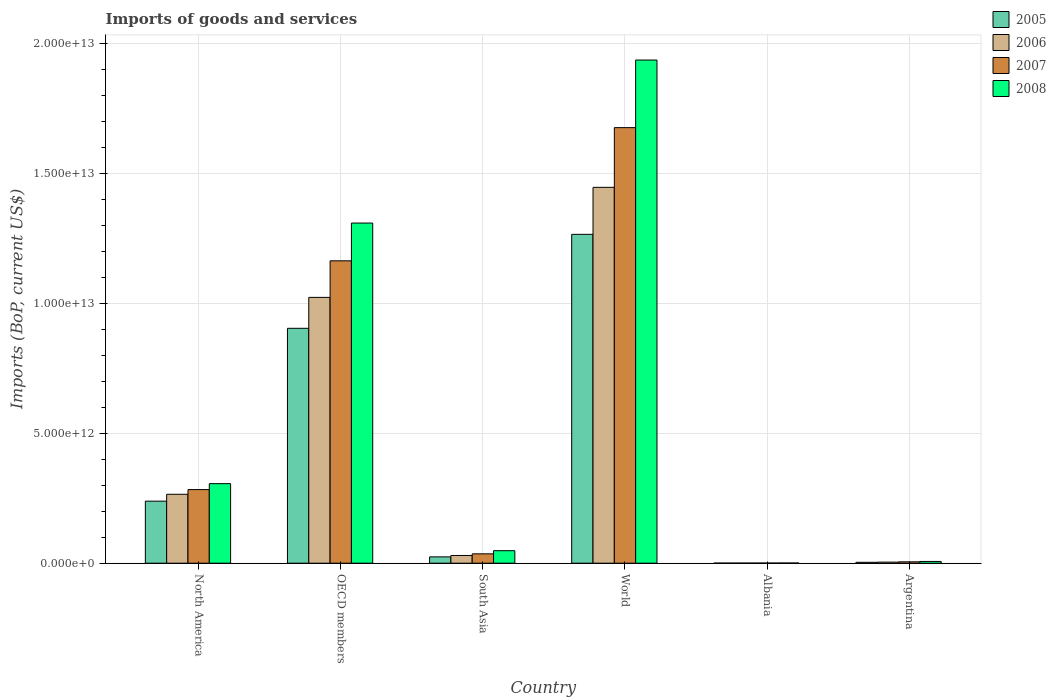How many different coloured bars are there?
Make the answer very short. 4. Are the number of bars on each tick of the X-axis equal?
Keep it short and to the point. Yes. How many bars are there on the 6th tick from the left?
Keep it short and to the point. 4. What is the label of the 5th group of bars from the left?
Offer a very short reply. Albania. In how many cases, is the number of bars for a given country not equal to the number of legend labels?
Offer a terse response. 0. What is the amount spent on imports in 2005 in OECD members?
Ensure brevity in your answer.  9.04e+12. Across all countries, what is the maximum amount spent on imports in 2005?
Your answer should be very brief. 1.27e+13. Across all countries, what is the minimum amount spent on imports in 2005?
Provide a short and direct response. 3.50e+09. In which country was the amount spent on imports in 2008 minimum?
Ensure brevity in your answer.  Albania. What is the total amount spent on imports in 2006 in the graph?
Make the answer very short. 2.77e+13. What is the difference between the amount spent on imports in 2006 in Argentina and that in World?
Make the answer very short. -1.44e+13. What is the difference between the amount spent on imports in 2005 in Argentina and the amount spent on imports in 2006 in Albania?
Provide a succinct answer. 3.07e+1. What is the average amount spent on imports in 2007 per country?
Make the answer very short. 5.27e+12. What is the difference between the amount spent on imports of/in 2007 and amount spent on imports of/in 2008 in North America?
Give a very brief answer. -2.28e+11. What is the ratio of the amount spent on imports in 2006 in Albania to that in South Asia?
Give a very brief answer. 0.01. Is the amount spent on imports in 2008 in Albania less than that in Argentina?
Offer a very short reply. Yes. Is the difference between the amount spent on imports in 2007 in Albania and OECD members greater than the difference between the amount spent on imports in 2008 in Albania and OECD members?
Keep it short and to the point. Yes. What is the difference between the highest and the second highest amount spent on imports in 2006?
Make the answer very short. 4.23e+12. What is the difference between the highest and the lowest amount spent on imports in 2005?
Offer a very short reply. 1.26e+13. In how many countries, is the amount spent on imports in 2006 greater than the average amount spent on imports in 2006 taken over all countries?
Your answer should be compact. 2. What does the 2nd bar from the right in North America represents?
Offer a very short reply. 2007. Is it the case that in every country, the sum of the amount spent on imports in 2006 and amount spent on imports in 2007 is greater than the amount spent on imports in 2008?
Provide a short and direct response. Yes. How many bars are there?
Give a very brief answer. 24. What is the difference between two consecutive major ticks on the Y-axis?
Give a very brief answer. 5.00e+12. Are the values on the major ticks of Y-axis written in scientific E-notation?
Your response must be concise. Yes. What is the title of the graph?
Ensure brevity in your answer.  Imports of goods and services. What is the label or title of the X-axis?
Your answer should be compact. Country. What is the label or title of the Y-axis?
Keep it short and to the point. Imports (BoP, current US$). What is the Imports (BoP, current US$) in 2005 in North America?
Keep it short and to the point. 2.39e+12. What is the Imports (BoP, current US$) in 2006 in North America?
Make the answer very short. 2.65e+12. What is the Imports (BoP, current US$) in 2007 in North America?
Provide a succinct answer. 2.83e+12. What is the Imports (BoP, current US$) of 2008 in North America?
Your answer should be very brief. 3.06e+12. What is the Imports (BoP, current US$) in 2005 in OECD members?
Your answer should be compact. 9.04e+12. What is the Imports (BoP, current US$) of 2006 in OECD members?
Keep it short and to the point. 1.02e+13. What is the Imports (BoP, current US$) in 2007 in OECD members?
Offer a terse response. 1.16e+13. What is the Imports (BoP, current US$) in 2008 in OECD members?
Your answer should be compact. 1.31e+13. What is the Imports (BoP, current US$) of 2005 in South Asia?
Provide a short and direct response. 2.43e+11. What is the Imports (BoP, current US$) in 2006 in South Asia?
Offer a very short reply. 2.97e+11. What is the Imports (BoP, current US$) in 2007 in South Asia?
Provide a short and direct response. 3.61e+11. What is the Imports (BoP, current US$) of 2008 in South Asia?
Offer a terse response. 4.81e+11. What is the Imports (BoP, current US$) of 2005 in World?
Offer a terse response. 1.27e+13. What is the Imports (BoP, current US$) in 2006 in World?
Your response must be concise. 1.45e+13. What is the Imports (BoP, current US$) in 2007 in World?
Give a very brief answer. 1.68e+13. What is the Imports (BoP, current US$) in 2008 in World?
Your answer should be very brief. 1.94e+13. What is the Imports (BoP, current US$) in 2005 in Albania?
Give a very brief answer. 3.50e+09. What is the Imports (BoP, current US$) in 2006 in Albania?
Give a very brief answer. 4.07e+09. What is the Imports (BoP, current US$) in 2007 in Albania?
Offer a very short reply. 5.34e+09. What is the Imports (BoP, current US$) in 2008 in Albania?
Offer a very short reply. 6.73e+09. What is the Imports (BoP, current US$) in 2005 in Argentina?
Provide a succinct answer. 3.48e+1. What is the Imports (BoP, current US$) of 2006 in Argentina?
Ensure brevity in your answer.  4.10e+1. What is the Imports (BoP, current US$) of 2007 in Argentina?
Make the answer very short. 5.32e+1. What is the Imports (BoP, current US$) of 2008 in Argentina?
Offer a terse response. 6.79e+1. Across all countries, what is the maximum Imports (BoP, current US$) in 2005?
Ensure brevity in your answer.  1.27e+13. Across all countries, what is the maximum Imports (BoP, current US$) in 2006?
Give a very brief answer. 1.45e+13. Across all countries, what is the maximum Imports (BoP, current US$) in 2007?
Offer a terse response. 1.68e+13. Across all countries, what is the maximum Imports (BoP, current US$) of 2008?
Your answer should be very brief. 1.94e+13. Across all countries, what is the minimum Imports (BoP, current US$) of 2005?
Offer a terse response. 3.50e+09. Across all countries, what is the minimum Imports (BoP, current US$) in 2006?
Provide a succinct answer. 4.07e+09. Across all countries, what is the minimum Imports (BoP, current US$) of 2007?
Offer a terse response. 5.34e+09. Across all countries, what is the minimum Imports (BoP, current US$) of 2008?
Make the answer very short. 6.73e+09. What is the total Imports (BoP, current US$) in 2005 in the graph?
Offer a very short reply. 2.44e+13. What is the total Imports (BoP, current US$) of 2006 in the graph?
Ensure brevity in your answer.  2.77e+13. What is the total Imports (BoP, current US$) in 2007 in the graph?
Ensure brevity in your answer.  3.16e+13. What is the total Imports (BoP, current US$) of 2008 in the graph?
Provide a succinct answer. 3.61e+13. What is the difference between the Imports (BoP, current US$) in 2005 in North America and that in OECD members?
Offer a very short reply. -6.65e+12. What is the difference between the Imports (BoP, current US$) of 2006 in North America and that in OECD members?
Your answer should be very brief. -7.57e+12. What is the difference between the Imports (BoP, current US$) in 2007 in North America and that in OECD members?
Your response must be concise. -8.80e+12. What is the difference between the Imports (BoP, current US$) in 2008 in North America and that in OECD members?
Your response must be concise. -1.00e+13. What is the difference between the Imports (BoP, current US$) in 2005 in North America and that in South Asia?
Provide a succinct answer. 2.14e+12. What is the difference between the Imports (BoP, current US$) of 2006 in North America and that in South Asia?
Provide a short and direct response. 2.35e+12. What is the difference between the Imports (BoP, current US$) of 2007 in North America and that in South Asia?
Provide a short and direct response. 2.47e+12. What is the difference between the Imports (BoP, current US$) of 2008 in North America and that in South Asia?
Offer a terse response. 2.58e+12. What is the difference between the Imports (BoP, current US$) in 2005 in North America and that in World?
Offer a terse response. -1.03e+13. What is the difference between the Imports (BoP, current US$) in 2006 in North America and that in World?
Offer a very short reply. -1.18e+13. What is the difference between the Imports (BoP, current US$) in 2007 in North America and that in World?
Offer a very short reply. -1.39e+13. What is the difference between the Imports (BoP, current US$) of 2008 in North America and that in World?
Provide a succinct answer. -1.63e+13. What is the difference between the Imports (BoP, current US$) of 2005 in North America and that in Albania?
Ensure brevity in your answer.  2.38e+12. What is the difference between the Imports (BoP, current US$) of 2006 in North America and that in Albania?
Make the answer very short. 2.65e+12. What is the difference between the Imports (BoP, current US$) in 2007 in North America and that in Albania?
Provide a succinct answer. 2.83e+12. What is the difference between the Imports (BoP, current US$) of 2008 in North America and that in Albania?
Make the answer very short. 3.05e+12. What is the difference between the Imports (BoP, current US$) in 2005 in North America and that in Argentina?
Provide a succinct answer. 2.35e+12. What is the difference between the Imports (BoP, current US$) in 2006 in North America and that in Argentina?
Your answer should be very brief. 2.61e+12. What is the difference between the Imports (BoP, current US$) in 2007 in North America and that in Argentina?
Your response must be concise. 2.78e+12. What is the difference between the Imports (BoP, current US$) in 2008 in North America and that in Argentina?
Offer a very short reply. 2.99e+12. What is the difference between the Imports (BoP, current US$) of 2005 in OECD members and that in South Asia?
Make the answer very short. 8.79e+12. What is the difference between the Imports (BoP, current US$) of 2006 in OECD members and that in South Asia?
Offer a very short reply. 9.93e+12. What is the difference between the Imports (BoP, current US$) in 2007 in OECD members and that in South Asia?
Offer a very short reply. 1.13e+13. What is the difference between the Imports (BoP, current US$) in 2008 in OECD members and that in South Asia?
Provide a succinct answer. 1.26e+13. What is the difference between the Imports (BoP, current US$) of 2005 in OECD members and that in World?
Give a very brief answer. -3.62e+12. What is the difference between the Imports (BoP, current US$) in 2006 in OECD members and that in World?
Your response must be concise. -4.23e+12. What is the difference between the Imports (BoP, current US$) in 2007 in OECD members and that in World?
Your response must be concise. -5.12e+12. What is the difference between the Imports (BoP, current US$) in 2008 in OECD members and that in World?
Make the answer very short. -6.27e+12. What is the difference between the Imports (BoP, current US$) of 2005 in OECD members and that in Albania?
Ensure brevity in your answer.  9.03e+12. What is the difference between the Imports (BoP, current US$) in 2006 in OECD members and that in Albania?
Ensure brevity in your answer.  1.02e+13. What is the difference between the Imports (BoP, current US$) in 2007 in OECD members and that in Albania?
Provide a succinct answer. 1.16e+13. What is the difference between the Imports (BoP, current US$) of 2008 in OECD members and that in Albania?
Give a very brief answer. 1.31e+13. What is the difference between the Imports (BoP, current US$) in 2005 in OECD members and that in Argentina?
Make the answer very short. 9.00e+12. What is the difference between the Imports (BoP, current US$) of 2006 in OECD members and that in Argentina?
Ensure brevity in your answer.  1.02e+13. What is the difference between the Imports (BoP, current US$) in 2007 in OECD members and that in Argentina?
Your response must be concise. 1.16e+13. What is the difference between the Imports (BoP, current US$) of 2008 in OECD members and that in Argentina?
Keep it short and to the point. 1.30e+13. What is the difference between the Imports (BoP, current US$) of 2005 in South Asia and that in World?
Provide a short and direct response. -1.24e+13. What is the difference between the Imports (BoP, current US$) of 2006 in South Asia and that in World?
Give a very brief answer. -1.42e+13. What is the difference between the Imports (BoP, current US$) of 2007 in South Asia and that in World?
Your response must be concise. -1.64e+13. What is the difference between the Imports (BoP, current US$) in 2008 in South Asia and that in World?
Offer a terse response. -1.89e+13. What is the difference between the Imports (BoP, current US$) in 2005 in South Asia and that in Albania?
Your response must be concise. 2.40e+11. What is the difference between the Imports (BoP, current US$) of 2006 in South Asia and that in Albania?
Your answer should be compact. 2.93e+11. What is the difference between the Imports (BoP, current US$) in 2007 in South Asia and that in Albania?
Offer a very short reply. 3.55e+11. What is the difference between the Imports (BoP, current US$) of 2008 in South Asia and that in Albania?
Make the answer very short. 4.74e+11. What is the difference between the Imports (BoP, current US$) of 2005 in South Asia and that in Argentina?
Offer a terse response. 2.09e+11. What is the difference between the Imports (BoP, current US$) in 2006 in South Asia and that in Argentina?
Ensure brevity in your answer.  2.56e+11. What is the difference between the Imports (BoP, current US$) of 2007 in South Asia and that in Argentina?
Offer a terse response. 3.07e+11. What is the difference between the Imports (BoP, current US$) of 2008 in South Asia and that in Argentina?
Your answer should be very brief. 4.13e+11. What is the difference between the Imports (BoP, current US$) in 2005 in World and that in Albania?
Keep it short and to the point. 1.26e+13. What is the difference between the Imports (BoP, current US$) in 2006 in World and that in Albania?
Offer a terse response. 1.45e+13. What is the difference between the Imports (BoP, current US$) of 2007 in World and that in Albania?
Provide a succinct answer. 1.68e+13. What is the difference between the Imports (BoP, current US$) of 2008 in World and that in Albania?
Your response must be concise. 1.93e+13. What is the difference between the Imports (BoP, current US$) in 2005 in World and that in Argentina?
Give a very brief answer. 1.26e+13. What is the difference between the Imports (BoP, current US$) of 2006 in World and that in Argentina?
Ensure brevity in your answer.  1.44e+13. What is the difference between the Imports (BoP, current US$) in 2007 in World and that in Argentina?
Make the answer very short. 1.67e+13. What is the difference between the Imports (BoP, current US$) in 2008 in World and that in Argentina?
Your response must be concise. 1.93e+13. What is the difference between the Imports (BoP, current US$) of 2005 in Albania and that in Argentina?
Your answer should be compact. -3.13e+1. What is the difference between the Imports (BoP, current US$) of 2006 in Albania and that in Argentina?
Ensure brevity in your answer.  -3.69e+1. What is the difference between the Imports (BoP, current US$) of 2007 in Albania and that in Argentina?
Make the answer very short. -4.79e+1. What is the difference between the Imports (BoP, current US$) of 2008 in Albania and that in Argentina?
Provide a short and direct response. -6.11e+1. What is the difference between the Imports (BoP, current US$) in 2005 in North America and the Imports (BoP, current US$) in 2006 in OECD members?
Give a very brief answer. -7.84e+12. What is the difference between the Imports (BoP, current US$) of 2005 in North America and the Imports (BoP, current US$) of 2007 in OECD members?
Your answer should be compact. -9.25e+12. What is the difference between the Imports (BoP, current US$) in 2005 in North America and the Imports (BoP, current US$) in 2008 in OECD members?
Your answer should be very brief. -1.07e+13. What is the difference between the Imports (BoP, current US$) in 2006 in North America and the Imports (BoP, current US$) in 2007 in OECD members?
Make the answer very short. -8.98e+12. What is the difference between the Imports (BoP, current US$) of 2006 in North America and the Imports (BoP, current US$) of 2008 in OECD members?
Your response must be concise. -1.04e+13. What is the difference between the Imports (BoP, current US$) of 2007 in North America and the Imports (BoP, current US$) of 2008 in OECD members?
Your answer should be very brief. -1.03e+13. What is the difference between the Imports (BoP, current US$) in 2005 in North America and the Imports (BoP, current US$) in 2006 in South Asia?
Your answer should be compact. 2.09e+12. What is the difference between the Imports (BoP, current US$) of 2005 in North America and the Imports (BoP, current US$) of 2007 in South Asia?
Give a very brief answer. 2.03e+12. What is the difference between the Imports (BoP, current US$) in 2005 in North America and the Imports (BoP, current US$) in 2008 in South Asia?
Offer a very short reply. 1.91e+12. What is the difference between the Imports (BoP, current US$) of 2006 in North America and the Imports (BoP, current US$) of 2007 in South Asia?
Offer a very short reply. 2.29e+12. What is the difference between the Imports (BoP, current US$) of 2006 in North America and the Imports (BoP, current US$) of 2008 in South Asia?
Offer a terse response. 2.17e+12. What is the difference between the Imports (BoP, current US$) in 2007 in North America and the Imports (BoP, current US$) in 2008 in South Asia?
Offer a terse response. 2.35e+12. What is the difference between the Imports (BoP, current US$) in 2005 in North America and the Imports (BoP, current US$) in 2006 in World?
Make the answer very short. -1.21e+13. What is the difference between the Imports (BoP, current US$) in 2005 in North America and the Imports (BoP, current US$) in 2007 in World?
Offer a very short reply. -1.44e+13. What is the difference between the Imports (BoP, current US$) in 2005 in North America and the Imports (BoP, current US$) in 2008 in World?
Offer a very short reply. -1.70e+13. What is the difference between the Imports (BoP, current US$) in 2006 in North America and the Imports (BoP, current US$) in 2007 in World?
Offer a terse response. -1.41e+13. What is the difference between the Imports (BoP, current US$) of 2006 in North America and the Imports (BoP, current US$) of 2008 in World?
Make the answer very short. -1.67e+13. What is the difference between the Imports (BoP, current US$) in 2007 in North America and the Imports (BoP, current US$) in 2008 in World?
Your answer should be very brief. -1.65e+13. What is the difference between the Imports (BoP, current US$) of 2005 in North America and the Imports (BoP, current US$) of 2006 in Albania?
Provide a short and direct response. 2.38e+12. What is the difference between the Imports (BoP, current US$) in 2005 in North America and the Imports (BoP, current US$) in 2007 in Albania?
Ensure brevity in your answer.  2.38e+12. What is the difference between the Imports (BoP, current US$) in 2005 in North America and the Imports (BoP, current US$) in 2008 in Albania?
Your response must be concise. 2.38e+12. What is the difference between the Imports (BoP, current US$) of 2006 in North America and the Imports (BoP, current US$) of 2007 in Albania?
Provide a succinct answer. 2.65e+12. What is the difference between the Imports (BoP, current US$) in 2006 in North America and the Imports (BoP, current US$) in 2008 in Albania?
Ensure brevity in your answer.  2.64e+12. What is the difference between the Imports (BoP, current US$) of 2007 in North America and the Imports (BoP, current US$) of 2008 in Albania?
Your response must be concise. 2.83e+12. What is the difference between the Imports (BoP, current US$) of 2005 in North America and the Imports (BoP, current US$) of 2006 in Argentina?
Provide a succinct answer. 2.35e+12. What is the difference between the Imports (BoP, current US$) of 2005 in North America and the Imports (BoP, current US$) of 2007 in Argentina?
Give a very brief answer. 2.33e+12. What is the difference between the Imports (BoP, current US$) of 2005 in North America and the Imports (BoP, current US$) of 2008 in Argentina?
Your answer should be very brief. 2.32e+12. What is the difference between the Imports (BoP, current US$) of 2006 in North America and the Imports (BoP, current US$) of 2007 in Argentina?
Offer a terse response. 2.60e+12. What is the difference between the Imports (BoP, current US$) of 2006 in North America and the Imports (BoP, current US$) of 2008 in Argentina?
Your response must be concise. 2.58e+12. What is the difference between the Imports (BoP, current US$) of 2007 in North America and the Imports (BoP, current US$) of 2008 in Argentina?
Offer a very short reply. 2.76e+12. What is the difference between the Imports (BoP, current US$) of 2005 in OECD members and the Imports (BoP, current US$) of 2006 in South Asia?
Make the answer very short. 8.74e+12. What is the difference between the Imports (BoP, current US$) in 2005 in OECD members and the Imports (BoP, current US$) in 2007 in South Asia?
Offer a terse response. 8.68e+12. What is the difference between the Imports (BoP, current US$) of 2005 in OECD members and the Imports (BoP, current US$) of 2008 in South Asia?
Offer a terse response. 8.55e+12. What is the difference between the Imports (BoP, current US$) of 2006 in OECD members and the Imports (BoP, current US$) of 2007 in South Asia?
Offer a very short reply. 9.87e+12. What is the difference between the Imports (BoP, current US$) of 2006 in OECD members and the Imports (BoP, current US$) of 2008 in South Asia?
Your answer should be compact. 9.74e+12. What is the difference between the Imports (BoP, current US$) in 2007 in OECD members and the Imports (BoP, current US$) in 2008 in South Asia?
Your response must be concise. 1.12e+13. What is the difference between the Imports (BoP, current US$) of 2005 in OECD members and the Imports (BoP, current US$) of 2006 in World?
Ensure brevity in your answer.  -5.42e+12. What is the difference between the Imports (BoP, current US$) of 2005 in OECD members and the Imports (BoP, current US$) of 2007 in World?
Give a very brief answer. -7.72e+12. What is the difference between the Imports (BoP, current US$) of 2005 in OECD members and the Imports (BoP, current US$) of 2008 in World?
Make the answer very short. -1.03e+13. What is the difference between the Imports (BoP, current US$) of 2006 in OECD members and the Imports (BoP, current US$) of 2007 in World?
Keep it short and to the point. -6.53e+12. What is the difference between the Imports (BoP, current US$) in 2006 in OECD members and the Imports (BoP, current US$) in 2008 in World?
Provide a succinct answer. -9.13e+12. What is the difference between the Imports (BoP, current US$) in 2007 in OECD members and the Imports (BoP, current US$) in 2008 in World?
Make the answer very short. -7.72e+12. What is the difference between the Imports (BoP, current US$) of 2005 in OECD members and the Imports (BoP, current US$) of 2006 in Albania?
Provide a succinct answer. 9.03e+12. What is the difference between the Imports (BoP, current US$) of 2005 in OECD members and the Imports (BoP, current US$) of 2007 in Albania?
Your answer should be compact. 9.03e+12. What is the difference between the Imports (BoP, current US$) of 2005 in OECD members and the Imports (BoP, current US$) of 2008 in Albania?
Your answer should be very brief. 9.03e+12. What is the difference between the Imports (BoP, current US$) of 2006 in OECD members and the Imports (BoP, current US$) of 2007 in Albania?
Your answer should be compact. 1.02e+13. What is the difference between the Imports (BoP, current US$) of 2006 in OECD members and the Imports (BoP, current US$) of 2008 in Albania?
Keep it short and to the point. 1.02e+13. What is the difference between the Imports (BoP, current US$) of 2007 in OECD members and the Imports (BoP, current US$) of 2008 in Albania?
Ensure brevity in your answer.  1.16e+13. What is the difference between the Imports (BoP, current US$) of 2005 in OECD members and the Imports (BoP, current US$) of 2006 in Argentina?
Your response must be concise. 9.00e+12. What is the difference between the Imports (BoP, current US$) of 2005 in OECD members and the Imports (BoP, current US$) of 2007 in Argentina?
Provide a succinct answer. 8.98e+12. What is the difference between the Imports (BoP, current US$) in 2005 in OECD members and the Imports (BoP, current US$) in 2008 in Argentina?
Your answer should be compact. 8.97e+12. What is the difference between the Imports (BoP, current US$) in 2006 in OECD members and the Imports (BoP, current US$) in 2007 in Argentina?
Make the answer very short. 1.02e+13. What is the difference between the Imports (BoP, current US$) in 2006 in OECD members and the Imports (BoP, current US$) in 2008 in Argentina?
Offer a terse response. 1.02e+13. What is the difference between the Imports (BoP, current US$) in 2007 in OECD members and the Imports (BoP, current US$) in 2008 in Argentina?
Give a very brief answer. 1.16e+13. What is the difference between the Imports (BoP, current US$) in 2005 in South Asia and the Imports (BoP, current US$) in 2006 in World?
Provide a succinct answer. -1.42e+13. What is the difference between the Imports (BoP, current US$) of 2005 in South Asia and the Imports (BoP, current US$) of 2007 in World?
Offer a very short reply. -1.65e+13. What is the difference between the Imports (BoP, current US$) in 2005 in South Asia and the Imports (BoP, current US$) in 2008 in World?
Give a very brief answer. -1.91e+13. What is the difference between the Imports (BoP, current US$) of 2006 in South Asia and the Imports (BoP, current US$) of 2007 in World?
Provide a succinct answer. -1.65e+13. What is the difference between the Imports (BoP, current US$) of 2006 in South Asia and the Imports (BoP, current US$) of 2008 in World?
Offer a terse response. -1.91e+13. What is the difference between the Imports (BoP, current US$) of 2007 in South Asia and the Imports (BoP, current US$) of 2008 in World?
Make the answer very short. -1.90e+13. What is the difference between the Imports (BoP, current US$) of 2005 in South Asia and the Imports (BoP, current US$) of 2006 in Albania?
Provide a succinct answer. 2.39e+11. What is the difference between the Imports (BoP, current US$) in 2005 in South Asia and the Imports (BoP, current US$) in 2007 in Albania?
Provide a succinct answer. 2.38e+11. What is the difference between the Imports (BoP, current US$) of 2005 in South Asia and the Imports (BoP, current US$) of 2008 in Albania?
Provide a succinct answer. 2.37e+11. What is the difference between the Imports (BoP, current US$) of 2006 in South Asia and the Imports (BoP, current US$) of 2007 in Albania?
Give a very brief answer. 2.92e+11. What is the difference between the Imports (BoP, current US$) in 2006 in South Asia and the Imports (BoP, current US$) in 2008 in Albania?
Ensure brevity in your answer.  2.91e+11. What is the difference between the Imports (BoP, current US$) in 2007 in South Asia and the Imports (BoP, current US$) in 2008 in Albania?
Provide a succinct answer. 3.54e+11. What is the difference between the Imports (BoP, current US$) in 2005 in South Asia and the Imports (BoP, current US$) in 2006 in Argentina?
Your answer should be very brief. 2.02e+11. What is the difference between the Imports (BoP, current US$) in 2005 in South Asia and the Imports (BoP, current US$) in 2007 in Argentina?
Offer a terse response. 1.90e+11. What is the difference between the Imports (BoP, current US$) in 2005 in South Asia and the Imports (BoP, current US$) in 2008 in Argentina?
Your answer should be very brief. 1.76e+11. What is the difference between the Imports (BoP, current US$) in 2006 in South Asia and the Imports (BoP, current US$) in 2007 in Argentina?
Your answer should be compact. 2.44e+11. What is the difference between the Imports (BoP, current US$) in 2006 in South Asia and the Imports (BoP, current US$) in 2008 in Argentina?
Your response must be concise. 2.30e+11. What is the difference between the Imports (BoP, current US$) of 2007 in South Asia and the Imports (BoP, current US$) of 2008 in Argentina?
Your response must be concise. 2.93e+11. What is the difference between the Imports (BoP, current US$) in 2005 in World and the Imports (BoP, current US$) in 2006 in Albania?
Provide a short and direct response. 1.26e+13. What is the difference between the Imports (BoP, current US$) in 2005 in World and the Imports (BoP, current US$) in 2007 in Albania?
Give a very brief answer. 1.26e+13. What is the difference between the Imports (BoP, current US$) in 2005 in World and the Imports (BoP, current US$) in 2008 in Albania?
Give a very brief answer. 1.26e+13. What is the difference between the Imports (BoP, current US$) in 2006 in World and the Imports (BoP, current US$) in 2007 in Albania?
Provide a short and direct response. 1.45e+13. What is the difference between the Imports (BoP, current US$) in 2006 in World and the Imports (BoP, current US$) in 2008 in Albania?
Ensure brevity in your answer.  1.45e+13. What is the difference between the Imports (BoP, current US$) of 2007 in World and the Imports (BoP, current US$) of 2008 in Albania?
Your response must be concise. 1.67e+13. What is the difference between the Imports (BoP, current US$) of 2005 in World and the Imports (BoP, current US$) of 2006 in Argentina?
Offer a very short reply. 1.26e+13. What is the difference between the Imports (BoP, current US$) of 2005 in World and the Imports (BoP, current US$) of 2007 in Argentina?
Provide a succinct answer. 1.26e+13. What is the difference between the Imports (BoP, current US$) in 2005 in World and the Imports (BoP, current US$) in 2008 in Argentina?
Provide a short and direct response. 1.26e+13. What is the difference between the Imports (BoP, current US$) of 2006 in World and the Imports (BoP, current US$) of 2007 in Argentina?
Keep it short and to the point. 1.44e+13. What is the difference between the Imports (BoP, current US$) in 2006 in World and the Imports (BoP, current US$) in 2008 in Argentina?
Your response must be concise. 1.44e+13. What is the difference between the Imports (BoP, current US$) in 2007 in World and the Imports (BoP, current US$) in 2008 in Argentina?
Your answer should be compact. 1.67e+13. What is the difference between the Imports (BoP, current US$) of 2005 in Albania and the Imports (BoP, current US$) of 2006 in Argentina?
Ensure brevity in your answer.  -3.75e+1. What is the difference between the Imports (BoP, current US$) in 2005 in Albania and the Imports (BoP, current US$) in 2007 in Argentina?
Your answer should be compact. -4.97e+1. What is the difference between the Imports (BoP, current US$) of 2005 in Albania and the Imports (BoP, current US$) of 2008 in Argentina?
Provide a short and direct response. -6.43e+1. What is the difference between the Imports (BoP, current US$) of 2006 in Albania and the Imports (BoP, current US$) of 2007 in Argentina?
Your answer should be compact. -4.92e+1. What is the difference between the Imports (BoP, current US$) of 2006 in Albania and the Imports (BoP, current US$) of 2008 in Argentina?
Ensure brevity in your answer.  -6.38e+1. What is the difference between the Imports (BoP, current US$) of 2007 in Albania and the Imports (BoP, current US$) of 2008 in Argentina?
Your answer should be compact. -6.25e+1. What is the average Imports (BoP, current US$) in 2005 per country?
Offer a very short reply. 4.06e+12. What is the average Imports (BoP, current US$) in 2006 per country?
Make the answer very short. 4.61e+12. What is the average Imports (BoP, current US$) of 2007 per country?
Keep it short and to the point. 5.27e+12. What is the average Imports (BoP, current US$) of 2008 per country?
Offer a very short reply. 6.01e+12. What is the difference between the Imports (BoP, current US$) of 2005 and Imports (BoP, current US$) of 2006 in North America?
Offer a very short reply. -2.65e+11. What is the difference between the Imports (BoP, current US$) of 2005 and Imports (BoP, current US$) of 2007 in North America?
Make the answer very short. -4.46e+11. What is the difference between the Imports (BoP, current US$) in 2005 and Imports (BoP, current US$) in 2008 in North America?
Provide a short and direct response. -6.74e+11. What is the difference between the Imports (BoP, current US$) in 2006 and Imports (BoP, current US$) in 2007 in North America?
Offer a terse response. -1.81e+11. What is the difference between the Imports (BoP, current US$) in 2006 and Imports (BoP, current US$) in 2008 in North America?
Provide a succinct answer. -4.09e+11. What is the difference between the Imports (BoP, current US$) in 2007 and Imports (BoP, current US$) in 2008 in North America?
Your answer should be compact. -2.28e+11. What is the difference between the Imports (BoP, current US$) in 2005 and Imports (BoP, current US$) in 2006 in OECD members?
Keep it short and to the point. -1.19e+12. What is the difference between the Imports (BoP, current US$) of 2005 and Imports (BoP, current US$) of 2007 in OECD members?
Offer a very short reply. -2.60e+12. What is the difference between the Imports (BoP, current US$) of 2005 and Imports (BoP, current US$) of 2008 in OECD members?
Ensure brevity in your answer.  -4.05e+12. What is the difference between the Imports (BoP, current US$) in 2006 and Imports (BoP, current US$) in 2007 in OECD members?
Your answer should be compact. -1.41e+12. What is the difference between the Imports (BoP, current US$) of 2006 and Imports (BoP, current US$) of 2008 in OECD members?
Ensure brevity in your answer.  -2.86e+12. What is the difference between the Imports (BoP, current US$) of 2007 and Imports (BoP, current US$) of 2008 in OECD members?
Ensure brevity in your answer.  -1.45e+12. What is the difference between the Imports (BoP, current US$) of 2005 and Imports (BoP, current US$) of 2006 in South Asia?
Your response must be concise. -5.40e+1. What is the difference between the Imports (BoP, current US$) of 2005 and Imports (BoP, current US$) of 2007 in South Asia?
Provide a short and direct response. -1.17e+11. What is the difference between the Imports (BoP, current US$) of 2005 and Imports (BoP, current US$) of 2008 in South Asia?
Offer a very short reply. -2.38e+11. What is the difference between the Imports (BoP, current US$) in 2006 and Imports (BoP, current US$) in 2007 in South Asia?
Give a very brief answer. -6.32e+1. What is the difference between the Imports (BoP, current US$) in 2006 and Imports (BoP, current US$) in 2008 in South Asia?
Provide a succinct answer. -1.84e+11. What is the difference between the Imports (BoP, current US$) of 2007 and Imports (BoP, current US$) of 2008 in South Asia?
Your answer should be compact. -1.21e+11. What is the difference between the Imports (BoP, current US$) in 2005 and Imports (BoP, current US$) in 2006 in World?
Provide a succinct answer. -1.81e+12. What is the difference between the Imports (BoP, current US$) in 2005 and Imports (BoP, current US$) in 2007 in World?
Keep it short and to the point. -4.10e+12. What is the difference between the Imports (BoP, current US$) of 2005 and Imports (BoP, current US$) of 2008 in World?
Give a very brief answer. -6.71e+12. What is the difference between the Imports (BoP, current US$) in 2006 and Imports (BoP, current US$) in 2007 in World?
Offer a terse response. -2.30e+12. What is the difference between the Imports (BoP, current US$) of 2006 and Imports (BoP, current US$) of 2008 in World?
Provide a succinct answer. -4.90e+12. What is the difference between the Imports (BoP, current US$) of 2007 and Imports (BoP, current US$) of 2008 in World?
Offer a very short reply. -2.60e+12. What is the difference between the Imports (BoP, current US$) in 2005 and Imports (BoP, current US$) in 2006 in Albania?
Provide a succinct answer. -5.73e+08. What is the difference between the Imports (BoP, current US$) in 2005 and Imports (BoP, current US$) in 2007 in Albania?
Offer a terse response. -1.84e+09. What is the difference between the Imports (BoP, current US$) in 2005 and Imports (BoP, current US$) in 2008 in Albania?
Your answer should be compact. -3.23e+09. What is the difference between the Imports (BoP, current US$) of 2006 and Imports (BoP, current US$) of 2007 in Albania?
Your response must be concise. -1.27e+09. What is the difference between the Imports (BoP, current US$) of 2006 and Imports (BoP, current US$) of 2008 in Albania?
Offer a very short reply. -2.66e+09. What is the difference between the Imports (BoP, current US$) of 2007 and Imports (BoP, current US$) of 2008 in Albania?
Offer a very short reply. -1.39e+09. What is the difference between the Imports (BoP, current US$) in 2005 and Imports (BoP, current US$) in 2006 in Argentina?
Your answer should be very brief. -6.18e+09. What is the difference between the Imports (BoP, current US$) of 2005 and Imports (BoP, current US$) of 2007 in Argentina?
Ensure brevity in your answer.  -1.84e+1. What is the difference between the Imports (BoP, current US$) of 2005 and Imports (BoP, current US$) of 2008 in Argentina?
Keep it short and to the point. -3.31e+1. What is the difference between the Imports (BoP, current US$) of 2006 and Imports (BoP, current US$) of 2007 in Argentina?
Keep it short and to the point. -1.23e+1. What is the difference between the Imports (BoP, current US$) of 2006 and Imports (BoP, current US$) of 2008 in Argentina?
Give a very brief answer. -2.69e+1. What is the difference between the Imports (BoP, current US$) of 2007 and Imports (BoP, current US$) of 2008 in Argentina?
Offer a terse response. -1.46e+1. What is the ratio of the Imports (BoP, current US$) in 2005 in North America to that in OECD members?
Your answer should be very brief. 0.26. What is the ratio of the Imports (BoP, current US$) of 2006 in North America to that in OECD members?
Your answer should be compact. 0.26. What is the ratio of the Imports (BoP, current US$) in 2007 in North America to that in OECD members?
Your response must be concise. 0.24. What is the ratio of the Imports (BoP, current US$) in 2008 in North America to that in OECD members?
Your answer should be very brief. 0.23. What is the ratio of the Imports (BoP, current US$) of 2005 in North America to that in South Asia?
Make the answer very short. 9.81. What is the ratio of the Imports (BoP, current US$) in 2006 in North America to that in South Asia?
Keep it short and to the point. 8.91. What is the ratio of the Imports (BoP, current US$) in 2007 in North America to that in South Asia?
Provide a short and direct response. 7.86. What is the ratio of the Imports (BoP, current US$) of 2008 in North America to that in South Asia?
Ensure brevity in your answer.  6.36. What is the ratio of the Imports (BoP, current US$) in 2005 in North America to that in World?
Provide a short and direct response. 0.19. What is the ratio of the Imports (BoP, current US$) in 2006 in North America to that in World?
Provide a short and direct response. 0.18. What is the ratio of the Imports (BoP, current US$) of 2007 in North America to that in World?
Your response must be concise. 0.17. What is the ratio of the Imports (BoP, current US$) in 2008 in North America to that in World?
Keep it short and to the point. 0.16. What is the ratio of the Imports (BoP, current US$) of 2005 in North America to that in Albania?
Your answer should be very brief. 681.78. What is the ratio of the Imports (BoP, current US$) of 2006 in North America to that in Albania?
Offer a very short reply. 650.85. What is the ratio of the Imports (BoP, current US$) of 2007 in North America to that in Albania?
Provide a succinct answer. 529.96. What is the ratio of the Imports (BoP, current US$) in 2008 in North America to that in Albania?
Ensure brevity in your answer.  454.64. What is the ratio of the Imports (BoP, current US$) of 2005 in North America to that in Argentina?
Provide a succinct answer. 68.58. What is the ratio of the Imports (BoP, current US$) of 2006 in North America to that in Argentina?
Ensure brevity in your answer.  64.7. What is the ratio of the Imports (BoP, current US$) in 2007 in North America to that in Argentina?
Keep it short and to the point. 53.21. What is the ratio of the Imports (BoP, current US$) in 2008 in North America to that in Argentina?
Make the answer very short. 45.1. What is the ratio of the Imports (BoP, current US$) of 2005 in OECD members to that in South Asia?
Provide a succinct answer. 37.13. What is the ratio of the Imports (BoP, current US$) in 2006 in OECD members to that in South Asia?
Provide a short and direct response. 34.39. What is the ratio of the Imports (BoP, current US$) of 2007 in OECD members to that in South Asia?
Give a very brief answer. 32.26. What is the ratio of the Imports (BoP, current US$) of 2008 in OECD members to that in South Asia?
Give a very brief answer. 27.19. What is the ratio of the Imports (BoP, current US$) of 2005 in OECD members to that in World?
Keep it short and to the point. 0.71. What is the ratio of the Imports (BoP, current US$) of 2006 in OECD members to that in World?
Give a very brief answer. 0.71. What is the ratio of the Imports (BoP, current US$) in 2007 in OECD members to that in World?
Provide a succinct answer. 0.69. What is the ratio of the Imports (BoP, current US$) of 2008 in OECD members to that in World?
Provide a short and direct response. 0.68. What is the ratio of the Imports (BoP, current US$) in 2005 in OECD members to that in Albania?
Offer a terse response. 2581.45. What is the ratio of the Imports (BoP, current US$) of 2006 in OECD members to that in Albania?
Your answer should be very brief. 2510.58. What is the ratio of the Imports (BoP, current US$) in 2007 in OECD members to that in Albania?
Give a very brief answer. 2176.63. What is the ratio of the Imports (BoP, current US$) of 2008 in OECD members to that in Albania?
Offer a terse response. 1944.04. What is the ratio of the Imports (BoP, current US$) of 2005 in OECD members to that in Argentina?
Your response must be concise. 259.68. What is the ratio of the Imports (BoP, current US$) in 2006 in OECD members to that in Argentina?
Keep it short and to the point. 249.57. What is the ratio of the Imports (BoP, current US$) in 2007 in OECD members to that in Argentina?
Keep it short and to the point. 218.54. What is the ratio of the Imports (BoP, current US$) of 2008 in OECD members to that in Argentina?
Offer a terse response. 192.85. What is the ratio of the Imports (BoP, current US$) in 2005 in South Asia to that in World?
Your answer should be compact. 0.02. What is the ratio of the Imports (BoP, current US$) in 2006 in South Asia to that in World?
Give a very brief answer. 0.02. What is the ratio of the Imports (BoP, current US$) of 2007 in South Asia to that in World?
Make the answer very short. 0.02. What is the ratio of the Imports (BoP, current US$) in 2008 in South Asia to that in World?
Offer a terse response. 0.02. What is the ratio of the Imports (BoP, current US$) of 2005 in South Asia to that in Albania?
Ensure brevity in your answer.  69.53. What is the ratio of the Imports (BoP, current US$) of 2006 in South Asia to that in Albania?
Offer a very short reply. 73.01. What is the ratio of the Imports (BoP, current US$) of 2007 in South Asia to that in Albania?
Your answer should be compact. 67.47. What is the ratio of the Imports (BoP, current US$) of 2008 in South Asia to that in Albania?
Your answer should be compact. 71.49. What is the ratio of the Imports (BoP, current US$) in 2005 in South Asia to that in Argentina?
Give a very brief answer. 6.99. What is the ratio of the Imports (BoP, current US$) in 2006 in South Asia to that in Argentina?
Offer a terse response. 7.26. What is the ratio of the Imports (BoP, current US$) of 2007 in South Asia to that in Argentina?
Give a very brief answer. 6.77. What is the ratio of the Imports (BoP, current US$) of 2008 in South Asia to that in Argentina?
Provide a short and direct response. 7.09. What is the ratio of the Imports (BoP, current US$) in 2005 in World to that in Albania?
Provide a short and direct response. 3614.24. What is the ratio of the Imports (BoP, current US$) in 2006 in World to that in Albania?
Make the answer very short. 3549.9. What is the ratio of the Imports (BoP, current US$) in 2007 in World to that in Albania?
Keep it short and to the point. 3135.35. What is the ratio of the Imports (BoP, current US$) of 2008 in World to that in Albania?
Your answer should be very brief. 2875.75. What is the ratio of the Imports (BoP, current US$) in 2005 in World to that in Argentina?
Offer a terse response. 363.57. What is the ratio of the Imports (BoP, current US$) of 2006 in World to that in Argentina?
Provide a short and direct response. 352.89. What is the ratio of the Imports (BoP, current US$) of 2007 in World to that in Argentina?
Keep it short and to the point. 314.8. What is the ratio of the Imports (BoP, current US$) of 2008 in World to that in Argentina?
Offer a terse response. 285.28. What is the ratio of the Imports (BoP, current US$) in 2005 in Albania to that in Argentina?
Keep it short and to the point. 0.1. What is the ratio of the Imports (BoP, current US$) in 2006 in Albania to that in Argentina?
Provide a succinct answer. 0.1. What is the ratio of the Imports (BoP, current US$) in 2007 in Albania to that in Argentina?
Keep it short and to the point. 0.1. What is the ratio of the Imports (BoP, current US$) of 2008 in Albania to that in Argentina?
Keep it short and to the point. 0.1. What is the difference between the highest and the second highest Imports (BoP, current US$) in 2005?
Provide a short and direct response. 3.62e+12. What is the difference between the highest and the second highest Imports (BoP, current US$) in 2006?
Provide a succinct answer. 4.23e+12. What is the difference between the highest and the second highest Imports (BoP, current US$) in 2007?
Provide a short and direct response. 5.12e+12. What is the difference between the highest and the second highest Imports (BoP, current US$) of 2008?
Your answer should be compact. 6.27e+12. What is the difference between the highest and the lowest Imports (BoP, current US$) in 2005?
Offer a very short reply. 1.26e+13. What is the difference between the highest and the lowest Imports (BoP, current US$) in 2006?
Offer a terse response. 1.45e+13. What is the difference between the highest and the lowest Imports (BoP, current US$) of 2007?
Keep it short and to the point. 1.68e+13. What is the difference between the highest and the lowest Imports (BoP, current US$) of 2008?
Offer a very short reply. 1.93e+13. 